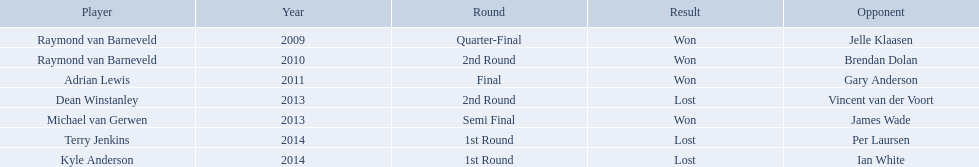Who were the players in 2014? Terry Jenkins, Kyle Anderson. Did they win or lose? Per Laursen. Who were all the players? Raymond van Barneveld, Raymond van Barneveld, Adrian Lewis, Dean Winstanley, Michael van Gerwen, Terry Jenkins, Kyle Anderson. Which of these played in 2014? Terry Jenkins, Kyle Anderson. Who were their opponents? Per Laursen, Ian White. Which of these beat terry jenkins? Per Laursen. What players competed in the pdc world darts championship? Raymond van Barneveld, Raymond van Barneveld, Adrian Lewis, Dean Winstanley, Michael van Gerwen, Terry Jenkins, Kyle Anderson. Of these players, who lost? Dean Winstanley, Terry Jenkins, Kyle Anderson. Which of these players lost in 2014? Terry Jenkins, Kyle Anderson. What are the players other than kyle anderson? Terry Jenkins. Who are the named players? Raymond van Barneveld, Raymond van Barneveld, Adrian Lewis, Dean Winstanley, Michael van Gerwen, Terry Jenkins, Kyle Anderson. Which of these competitors took part in 2011? Adrian Lewis. Who were all the participants? Raymond van Barneveld, Raymond van Barneveld, Adrian Lewis, Dean Winstanley, Michael van Gerwen, Terry Jenkins, Kyle Anderson. Which of them played in 2014? Terry Jenkins, Kyle Anderson. Who were their adversaries? Per Laursen, Ian White. Which of these defeated terry jenkins? Per Laursen. Who are the participants in the pdc world darts championship? Raymond van Barneveld, Raymond van Barneveld, Adrian Lewis, Dean Winstanley, Michael van Gerwen, Terry Jenkins, Kyle Anderson. When was kyle anderson defeated? 2014. Which other competitors lost in 2014? Terry Jenkins. Who are the listed participants? Raymond van Barneveld, Raymond van Barneveld, Adrian Lewis, Dean Winstanley, Michael van Gerwen, Terry Jenkins, Kyle Anderson. Which of these individuals played in 2011? Adrian Lewis. Who are the contenders in the pdc world darts championship? Raymond van Barneveld, Raymond van Barneveld, Adrian Lewis, Dean Winstanley, Michael van Gerwen, Terry Jenkins, Kyle Anderson. When did kyle anderson experience a loss? 2014. Which other participants were beaten in 2014? Terry Jenkins. Would you mind parsing the complete table? {'header': ['Player', 'Year', 'Round', 'Result', 'Opponent'], 'rows': [['Raymond van Barneveld', '2009', 'Quarter-Final', 'Won', 'Jelle Klaasen'], ['Raymond van Barneveld', '2010', '2nd Round', 'Won', 'Brendan Dolan'], ['Adrian Lewis', '2011', 'Final', 'Won', 'Gary Anderson'], ['Dean Winstanley', '2013', '2nd Round', 'Lost', 'Vincent van der Voort'], ['Michael van Gerwen', '2013', 'Semi Final', 'Won', 'James Wade'], ['Terry Jenkins', '2014', '1st Round', 'Lost', 'Per Laursen'], ['Kyle Anderson', '2014', '1st Round', 'Lost', 'Ian White']]} Who are all the members? Raymond van Barneveld, Raymond van Barneveld, Adrian Lewis, Dean Winstanley, Michael van Gerwen, Terry Jenkins, Kyle Anderson. When did they perform? 2009, 2010, 2011, 2013, 2013, 2014, 2014. And which member performed in 2011? Adrian Lewis. What were the titles of all the athletes? Raymond van Barneveld, Raymond van Barneveld, Adrian Lewis, Dean Winstanley, Michael van Gerwen, Terry Jenkins, Kyle Anderson. In what years was the championship presented? 2009, 2010, 2011, 2013, 2013, 2014, 2014. Out of these, who took part in 2011? Adrian Lewis. Can you give me this table as a dict? {'header': ['Player', 'Year', 'Round', 'Result', 'Opponent'], 'rows': [['Raymond van Barneveld', '2009', 'Quarter-Final', 'Won', 'Jelle Klaasen'], ['Raymond van Barneveld', '2010', '2nd Round', 'Won', 'Brendan Dolan'], ['Adrian Lewis', '2011', 'Final', 'Won', 'Gary Anderson'], ['Dean Winstanley', '2013', '2nd Round', 'Lost', 'Vincent van der Voort'], ['Michael van Gerwen', '2013', 'Semi Final', 'Won', 'James Wade'], ['Terry Jenkins', '2014', '1st Round', 'Lost', 'Per Laursen'], ['Kyle Anderson', '2014', '1st Round', 'Lost', 'Ian White']]} What were the names of each player? Raymond van Barneveld, Raymond van Barneveld, Adrian Lewis, Dean Winstanley, Michael van Gerwen, Terry Jenkins, Kyle Anderson. In which years was the championship held? 2009, 2010, 2011, 2013, 2013, 2014, 2014. Among them, who participated in 2011? Adrian Lewis. Can you provide the names of all the players? Raymond van Barneveld, Raymond van Barneveld, Adrian Lewis, Dean Winstanley, Michael van Gerwen, Terry Jenkins, Kyle Anderson. In which years did the championship take place? 2009, 2010, 2011, 2013, 2013, 2014, 2014. Who among them played in the 2011 championship? Adrian Lewis. Can you provide the names of the players listed? Raymond van Barneveld, Raymond van Barneveld, Adrian Lewis, Dean Winstanley, Michael van Gerwen, Terry Jenkins, Kyle Anderson. Who among them took part in 2011? Adrian Lewis. Was terry jenkins victorious in 2014? Terry Jenkins, Lost. If he was defeated, who emerged as the winner? Per Laursen. Did terry jenkins achieve a win in 2014? Terry Jenkins, Lost. If he lost, who was the successful competitor? Per Laursen. In 2014, which players were involved? Terry Jenkins, Kyle Anderson. Were they victorious or defeated? Per Laursen. Who were all the participants? Raymond van Barneveld, Raymond van Barneveld, Adrian Lewis, Dean Winstanley, Michael van Gerwen, Terry Jenkins, Kyle Anderson. Which ones took part in 2014? Terry Jenkins, Kyle Anderson. Who did they compete against? Per Laursen, Ian White. Which of them defeated terry jenkins? Per Laursen. Can you give me this table as a dict? {'header': ['Player', 'Year', 'Round', 'Result', 'Opponent'], 'rows': [['Raymond van Barneveld', '2009', 'Quarter-Final', 'Won', 'Jelle Klaasen'], ['Raymond van Barneveld', '2010', '2nd Round', 'Won', 'Brendan Dolan'], ['Adrian Lewis', '2011', 'Final', 'Won', 'Gary Anderson'], ['Dean Winstanley', '2013', '2nd Round', 'Lost', 'Vincent van der Voort'], ['Michael van Gerwen', '2013', 'Semi Final', 'Won', 'James Wade'], ['Terry Jenkins', '2014', '1st Round', 'Lost', 'Per Laursen'], ['Kyle Anderson', '2014', '1st Round', 'Lost', 'Ian White']]} Who were the complete list of players? Raymond van Barneveld, Raymond van Barneveld, Adrian Lewis, Dean Winstanley, Michael van Gerwen, Terry Jenkins, Kyle Anderson. Which among them participated in 2014? Terry Jenkins, Kyle Anderson. Who were the adversaries? Per Laursen, Ian White. Which players won against terry jenkins? Per Laursen. Who are the participants in the pdc world darts championship? Raymond van Barneveld, Raymond van Barneveld, Adrian Lewis, Dean Winstanley, Michael van Gerwen, Terry Jenkins, Kyle Anderson. When was kyle anderson defeated? 2014. Who else was eliminated in 2014? Terry Jenkins. 